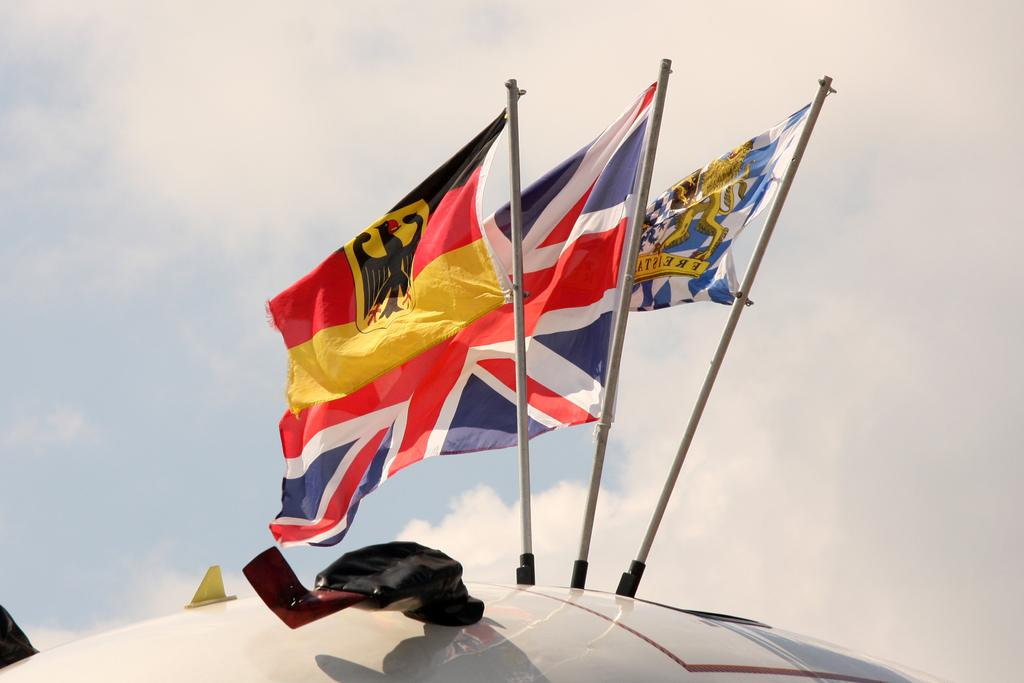How many flags are present in the image? There are three flags with poles in the image. What are the flags attached to? The flags are attached to a metal object. What can be seen in the background of the image? The sky is visible behind the flags. What type of rake is being used to clean the flags in the image? There is no rake present in the image, and the flags are not being cleaned. 